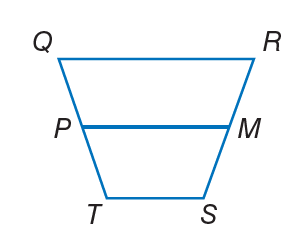Answer the mathemtical geometry problem and directly provide the correct option letter.
Question: For trapezoid Q R S T, M and P are midpoints of the legs. If P M = 2 x, Q R = 3 x, and T S = 10, find P M.
Choices: A: 8 B: 12 C: 16 D: 20 D 